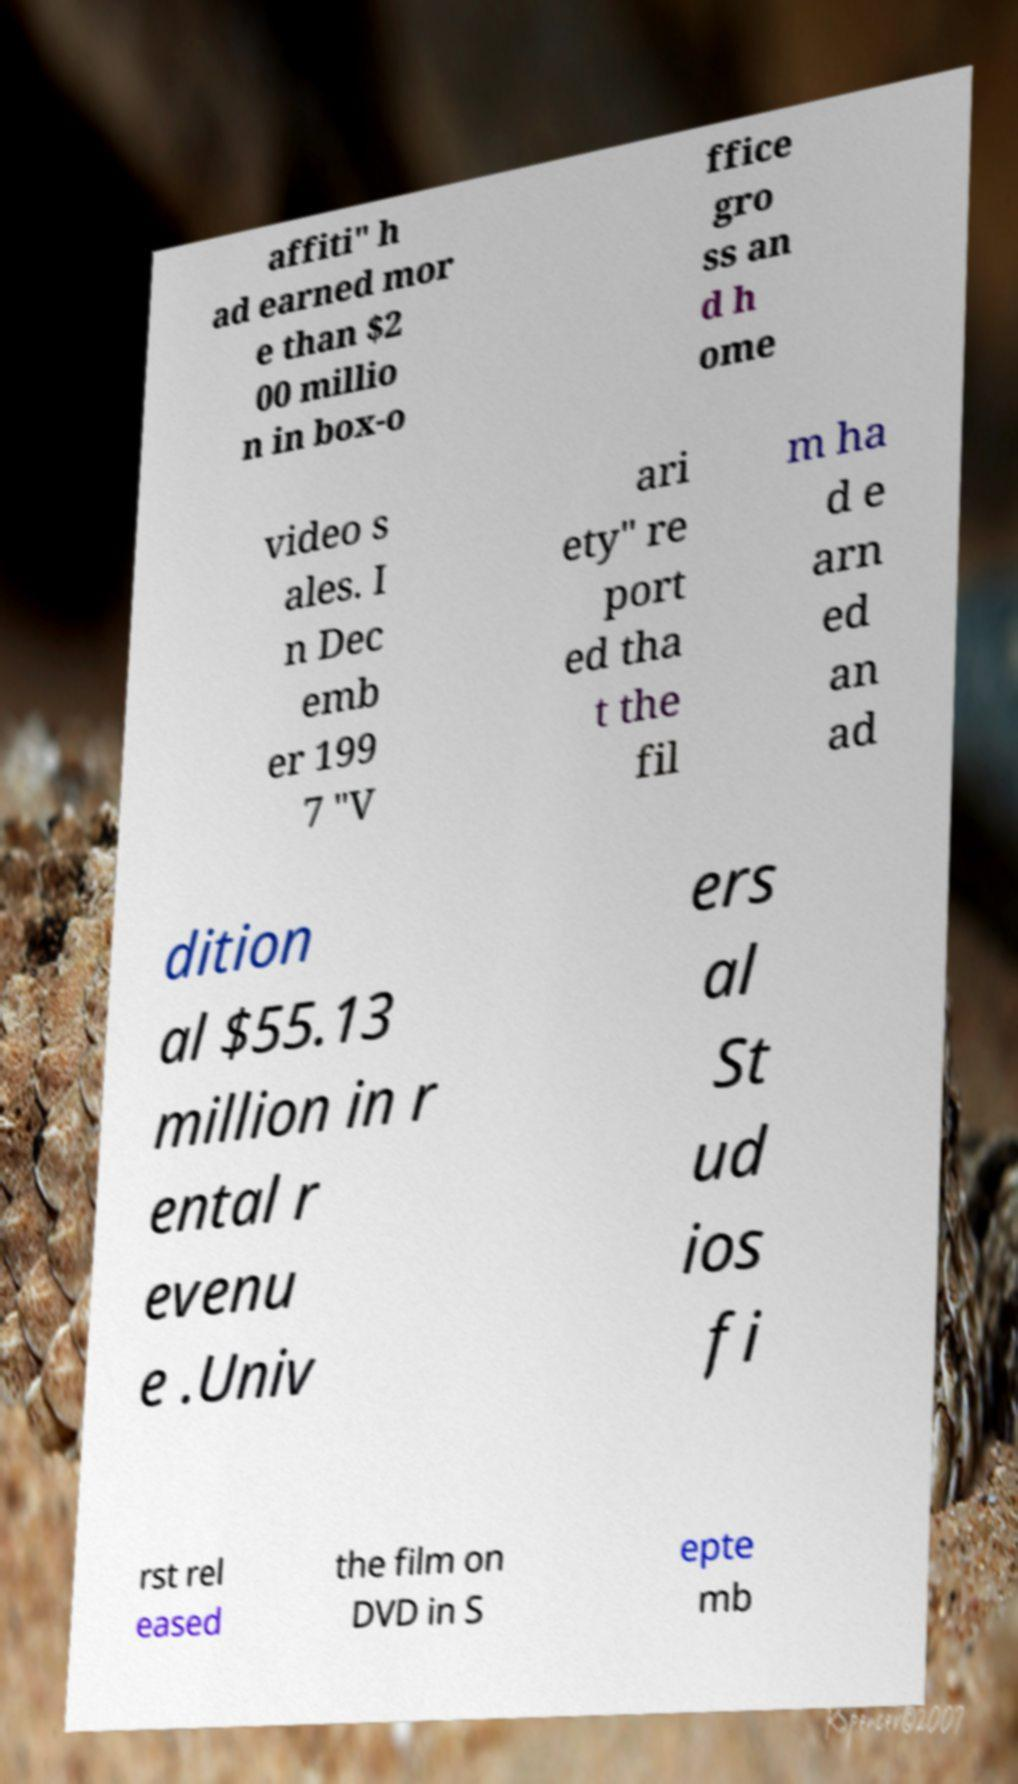There's text embedded in this image that I need extracted. Can you transcribe it verbatim? affiti" h ad earned mor e than $2 00 millio n in box-o ffice gro ss an d h ome video s ales. I n Dec emb er 199 7 "V ari ety" re port ed tha t the fil m ha d e arn ed an ad dition al $55.13 million in r ental r evenu e .Univ ers al St ud ios fi rst rel eased the film on DVD in S epte mb 